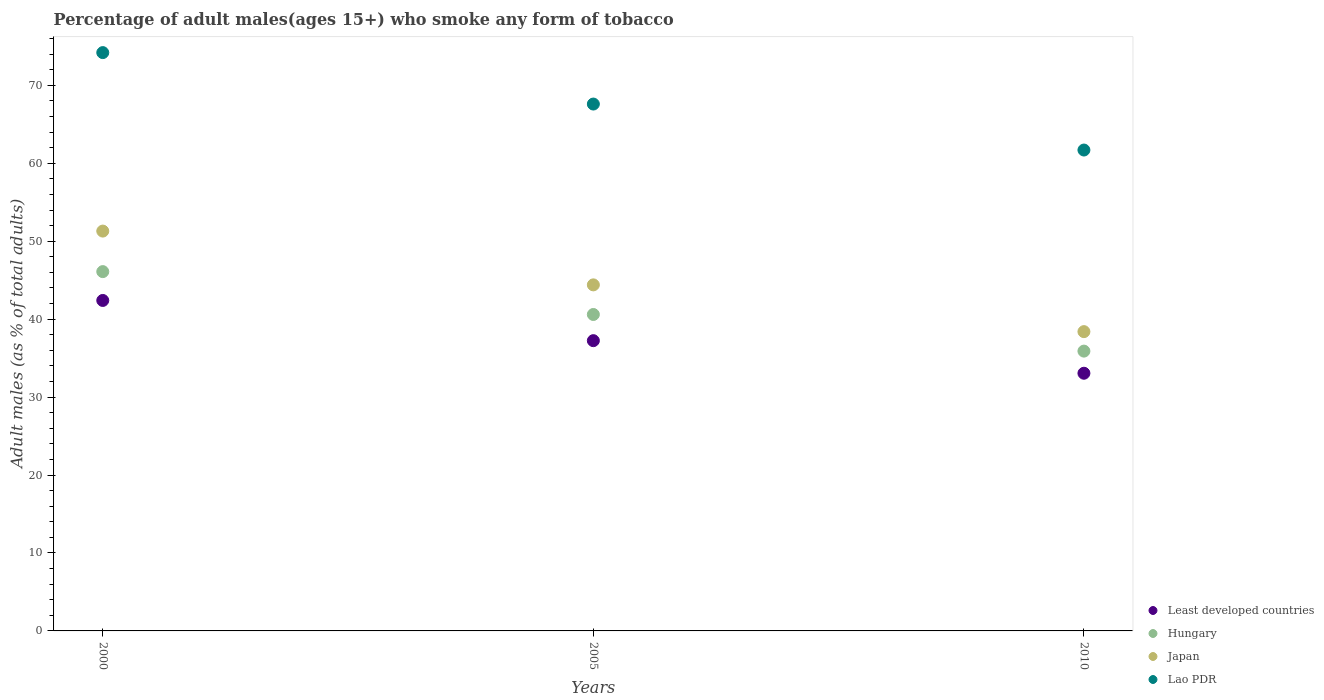How many different coloured dotlines are there?
Your answer should be very brief. 4. What is the percentage of adult males who smoke in Least developed countries in 2010?
Keep it short and to the point. 33.06. Across all years, what is the maximum percentage of adult males who smoke in Lao PDR?
Give a very brief answer. 74.2. Across all years, what is the minimum percentage of adult males who smoke in Japan?
Your answer should be compact. 38.4. In which year was the percentage of adult males who smoke in Hungary minimum?
Make the answer very short. 2010. What is the total percentage of adult males who smoke in Least developed countries in the graph?
Your answer should be very brief. 112.7. What is the difference between the percentage of adult males who smoke in Hungary in 2005 and the percentage of adult males who smoke in Lao PDR in 2000?
Ensure brevity in your answer.  -33.6. What is the average percentage of adult males who smoke in Japan per year?
Your answer should be very brief. 44.7. In the year 2005, what is the difference between the percentage of adult males who smoke in Lao PDR and percentage of adult males who smoke in Japan?
Your answer should be compact. 23.2. What is the ratio of the percentage of adult males who smoke in Least developed countries in 2005 to that in 2010?
Offer a terse response. 1.13. Is the difference between the percentage of adult males who smoke in Lao PDR in 2000 and 2005 greater than the difference between the percentage of adult males who smoke in Japan in 2000 and 2005?
Keep it short and to the point. No. What is the difference between the highest and the second highest percentage of adult males who smoke in Least developed countries?
Provide a succinct answer. 5.16. What is the difference between the highest and the lowest percentage of adult males who smoke in Least developed countries?
Your answer should be compact. 9.34. In how many years, is the percentage of adult males who smoke in Least developed countries greater than the average percentage of adult males who smoke in Least developed countries taken over all years?
Offer a very short reply. 1. Is it the case that in every year, the sum of the percentage of adult males who smoke in Hungary and percentage of adult males who smoke in Least developed countries  is greater than the sum of percentage of adult males who smoke in Japan and percentage of adult males who smoke in Lao PDR?
Your answer should be very brief. No. Is it the case that in every year, the sum of the percentage of adult males who smoke in Lao PDR and percentage of adult males who smoke in Japan  is greater than the percentage of adult males who smoke in Least developed countries?
Give a very brief answer. Yes. Does the percentage of adult males who smoke in Japan monotonically increase over the years?
Provide a short and direct response. No. Is the percentage of adult males who smoke in Least developed countries strictly less than the percentage of adult males who smoke in Japan over the years?
Give a very brief answer. Yes. How many dotlines are there?
Ensure brevity in your answer.  4. How many years are there in the graph?
Your answer should be compact. 3. What is the difference between two consecutive major ticks on the Y-axis?
Give a very brief answer. 10. Are the values on the major ticks of Y-axis written in scientific E-notation?
Provide a succinct answer. No. How are the legend labels stacked?
Your answer should be compact. Vertical. What is the title of the graph?
Give a very brief answer. Percentage of adult males(ages 15+) who smoke any form of tobacco. Does "Guam" appear as one of the legend labels in the graph?
Keep it short and to the point. No. What is the label or title of the X-axis?
Offer a terse response. Years. What is the label or title of the Y-axis?
Give a very brief answer. Adult males (as % of total adults). What is the Adult males (as % of total adults) in Least developed countries in 2000?
Your answer should be compact. 42.4. What is the Adult males (as % of total adults) of Hungary in 2000?
Offer a very short reply. 46.1. What is the Adult males (as % of total adults) in Japan in 2000?
Your response must be concise. 51.3. What is the Adult males (as % of total adults) of Lao PDR in 2000?
Offer a very short reply. 74.2. What is the Adult males (as % of total adults) of Least developed countries in 2005?
Give a very brief answer. 37.24. What is the Adult males (as % of total adults) of Hungary in 2005?
Your answer should be very brief. 40.6. What is the Adult males (as % of total adults) in Japan in 2005?
Your response must be concise. 44.4. What is the Adult males (as % of total adults) in Lao PDR in 2005?
Your response must be concise. 67.6. What is the Adult males (as % of total adults) of Least developed countries in 2010?
Give a very brief answer. 33.06. What is the Adult males (as % of total adults) in Hungary in 2010?
Ensure brevity in your answer.  35.9. What is the Adult males (as % of total adults) of Japan in 2010?
Provide a succinct answer. 38.4. What is the Adult males (as % of total adults) in Lao PDR in 2010?
Your answer should be very brief. 61.7. Across all years, what is the maximum Adult males (as % of total adults) in Least developed countries?
Make the answer very short. 42.4. Across all years, what is the maximum Adult males (as % of total adults) of Hungary?
Your answer should be compact. 46.1. Across all years, what is the maximum Adult males (as % of total adults) in Japan?
Ensure brevity in your answer.  51.3. Across all years, what is the maximum Adult males (as % of total adults) in Lao PDR?
Your answer should be compact. 74.2. Across all years, what is the minimum Adult males (as % of total adults) of Least developed countries?
Keep it short and to the point. 33.06. Across all years, what is the minimum Adult males (as % of total adults) of Hungary?
Provide a short and direct response. 35.9. Across all years, what is the minimum Adult males (as % of total adults) of Japan?
Make the answer very short. 38.4. Across all years, what is the minimum Adult males (as % of total adults) in Lao PDR?
Your answer should be compact. 61.7. What is the total Adult males (as % of total adults) in Least developed countries in the graph?
Give a very brief answer. 112.7. What is the total Adult males (as % of total adults) of Hungary in the graph?
Your response must be concise. 122.6. What is the total Adult males (as % of total adults) in Japan in the graph?
Ensure brevity in your answer.  134.1. What is the total Adult males (as % of total adults) of Lao PDR in the graph?
Your response must be concise. 203.5. What is the difference between the Adult males (as % of total adults) in Least developed countries in 2000 and that in 2005?
Your answer should be very brief. 5.16. What is the difference between the Adult males (as % of total adults) of Least developed countries in 2000 and that in 2010?
Keep it short and to the point. 9.34. What is the difference between the Adult males (as % of total adults) of Hungary in 2000 and that in 2010?
Provide a short and direct response. 10.2. What is the difference between the Adult males (as % of total adults) of Japan in 2000 and that in 2010?
Give a very brief answer. 12.9. What is the difference between the Adult males (as % of total adults) in Least developed countries in 2005 and that in 2010?
Keep it short and to the point. 4.18. What is the difference between the Adult males (as % of total adults) in Hungary in 2005 and that in 2010?
Make the answer very short. 4.7. What is the difference between the Adult males (as % of total adults) in Lao PDR in 2005 and that in 2010?
Give a very brief answer. 5.9. What is the difference between the Adult males (as % of total adults) in Least developed countries in 2000 and the Adult males (as % of total adults) in Hungary in 2005?
Keep it short and to the point. 1.8. What is the difference between the Adult males (as % of total adults) in Least developed countries in 2000 and the Adult males (as % of total adults) in Japan in 2005?
Ensure brevity in your answer.  -2. What is the difference between the Adult males (as % of total adults) of Least developed countries in 2000 and the Adult males (as % of total adults) of Lao PDR in 2005?
Your answer should be compact. -25.2. What is the difference between the Adult males (as % of total adults) in Hungary in 2000 and the Adult males (as % of total adults) in Lao PDR in 2005?
Keep it short and to the point. -21.5. What is the difference between the Adult males (as % of total adults) of Japan in 2000 and the Adult males (as % of total adults) of Lao PDR in 2005?
Offer a terse response. -16.3. What is the difference between the Adult males (as % of total adults) in Least developed countries in 2000 and the Adult males (as % of total adults) in Hungary in 2010?
Your response must be concise. 6.5. What is the difference between the Adult males (as % of total adults) in Least developed countries in 2000 and the Adult males (as % of total adults) in Japan in 2010?
Your answer should be compact. 4. What is the difference between the Adult males (as % of total adults) in Least developed countries in 2000 and the Adult males (as % of total adults) in Lao PDR in 2010?
Your answer should be very brief. -19.3. What is the difference between the Adult males (as % of total adults) of Hungary in 2000 and the Adult males (as % of total adults) of Japan in 2010?
Give a very brief answer. 7.7. What is the difference between the Adult males (as % of total adults) of Hungary in 2000 and the Adult males (as % of total adults) of Lao PDR in 2010?
Make the answer very short. -15.6. What is the difference between the Adult males (as % of total adults) of Least developed countries in 2005 and the Adult males (as % of total adults) of Hungary in 2010?
Ensure brevity in your answer.  1.34. What is the difference between the Adult males (as % of total adults) of Least developed countries in 2005 and the Adult males (as % of total adults) of Japan in 2010?
Provide a succinct answer. -1.16. What is the difference between the Adult males (as % of total adults) in Least developed countries in 2005 and the Adult males (as % of total adults) in Lao PDR in 2010?
Your response must be concise. -24.46. What is the difference between the Adult males (as % of total adults) in Hungary in 2005 and the Adult males (as % of total adults) in Lao PDR in 2010?
Ensure brevity in your answer.  -21.1. What is the difference between the Adult males (as % of total adults) of Japan in 2005 and the Adult males (as % of total adults) of Lao PDR in 2010?
Offer a terse response. -17.3. What is the average Adult males (as % of total adults) of Least developed countries per year?
Give a very brief answer. 37.57. What is the average Adult males (as % of total adults) of Hungary per year?
Make the answer very short. 40.87. What is the average Adult males (as % of total adults) of Japan per year?
Offer a very short reply. 44.7. What is the average Adult males (as % of total adults) of Lao PDR per year?
Your answer should be compact. 67.83. In the year 2000, what is the difference between the Adult males (as % of total adults) of Least developed countries and Adult males (as % of total adults) of Hungary?
Your answer should be very brief. -3.7. In the year 2000, what is the difference between the Adult males (as % of total adults) in Least developed countries and Adult males (as % of total adults) in Japan?
Give a very brief answer. -8.9. In the year 2000, what is the difference between the Adult males (as % of total adults) of Least developed countries and Adult males (as % of total adults) of Lao PDR?
Ensure brevity in your answer.  -31.8. In the year 2000, what is the difference between the Adult males (as % of total adults) of Hungary and Adult males (as % of total adults) of Lao PDR?
Ensure brevity in your answer.  -28.1. In the year 2000, what is the difference between the Adult males (as % of total adults) in Japan and Adult males (as % of total adults) in Lao PDR?
Provide a short and direct response. -22.9. In the year 2005, what is the difference between the Adult males (as % of total adults) of Least developed countries and Adult males (as % of total adults) of Hungary?
Provide a short and direct response. -3.36. In the year 2005, what is the difference between the Adult males (as % of total adults) in Least developed countries and Adult males (as % of total adults) in Japan?
Ensure brevity in your answer.  -7.16. In the year 2005, what is the difference between the Adult males (as % of total adults) of Least developed countries and Adult males (as % of total adults) of Lao PDR?
Your answer should be compact. -30.36. In the year 2005, what is the difference between the Adult males (as % of total adults) of Hungary and Adult males (as % of total adults) of Lao PDR?
Keep it short and to the point. -27. In the year 2005, what is the difference between the Adult males (as % of total adults) of Japan and Adult males (as % of total adults) of Lao PDR?
Your answer should be compact. -23.2. In the year 2010, what is the difference between the Adult males (as % of total adults) in Least developed countries and Adult males (as % of total adults) in Hungary?
Offer a very short reply. -2.84. In the year 2010, what is the difference between the Adult males (as % of total adults) of Least developed countries and Adult males (as % of total adults) of Japan?
Offer a terse response. -5.34. In the year 2010, what is the difference between the Adult males (as % of total adults) in Least developed countries and Adult males (as % of total adults) in Lao PDR?
Provide a short and direct response. -28.64. In the year 2010, what is the difference between the Adult males (as % of total adults) of Hungary and Adult males (as % of total adults) of Lao PDR?
Make the answer very short. -25.8. In the year 2010, what is the difference between the Adult males (as % of total adults) of Japan and Adult males (as % of total adults) of Lao PDR?
Provide a succinct answer. -23.3. What is the ratio of the Adult males (as % of total adults) of Least developed countries in 2000 to that in 2005?
Make the answer very short. 1.14. What is the ratio of the Adult males (as % of total adults) in Hungary in 2000 to that in 2005?
Offer a very short reply. 1.14. What is the ratio of the Adult males (as % of total adults) in Japan in 2000 to that in 2005?
Provide a short and direct response. 1.16. What is the ratio of the Adult males (as % of total adults) of Lao PDR in 2000 to that in 2005?
Ensure brevity in your answer.  1.1. What is the ratio of the Adult males (as % of total adults) of Least developed countries in 2000 to that in 2010?
Provide a short and direct response. 1.28. What is the ratio of the Adult males (as % of total adults) of Hungary in 2000 to that in 2010?
Make the answer very short. 1.28. What is the ratio of the Adult males (as % of total adults) in Japan in 2000 to that in 2010?
Your answer should be compact. 1.34. What is the ratio of the Adult males (as % of total adults) of Lao PDR in 2000 to that in 2010?
Your answer should be very brief. 1.2. What is the ratio of the Adult males (as % of total adults) of Least developed countries in 2005 to that in 2010?
Offer a terse response. 1.13. What is the ratio of the Adult males (as % of total adults) of Hungary in 2005 to that in 2010?
Make the answer very short. 1.13. What is the ratio of the Adult males (as % of total adults) in Japan in 2005 to that in 2010?
Ensure brevity in your answer.  1.16. What is the ratio of the Adult males (as % of total adults) in Lao PDR in 2005 to that in 2010?
Give a very brief answer. 1.1. What is the difference between the highest and the second highest Adult males (as % of total adults) in Least developed countries?
Your answer should be very brief. 5.16. What is the difference between the highest and the second highest Adult males (as % of total adults) of Japan?
Ensure brevity in your answer.  6.9. What is the difference between the highest and the lowest Adult males (as % of total adults) of Least developed countries?
Provide a succinct answer. 9.34. What is the difference between the highest and the lowest Adult males (as % of total adults) of Hungary?
Your answer should be compact. 10.2. What is the difference between the highest and the lowest Adult males (as % of total adults) of Japan?
Provide a short and direct response. 12.9. What is the difference between the highest and the lowest Adult males (as % of total adults) in Lao PDR?
Offer a terse response. 12.5. 